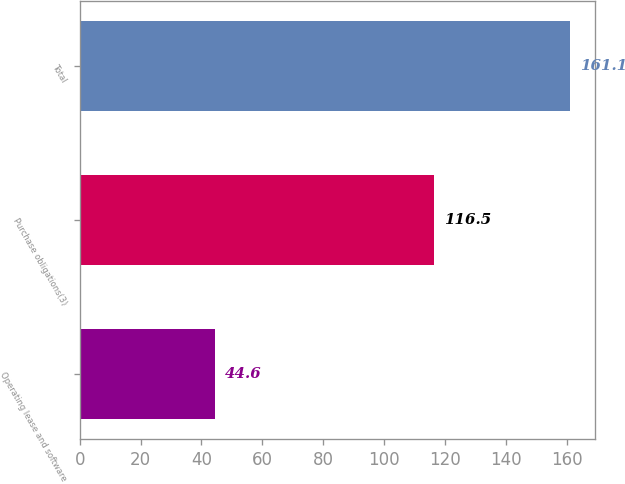Convert chart. <chart><loc_0><loc_0><loc_500><loc_500><bar_chart><fcel>Operating lease and software<fcel>Purchase obligations(3)<fcel>Total<nl><fcel>44.6<fcel>116.5<fcel>161.1<nl></chart> 